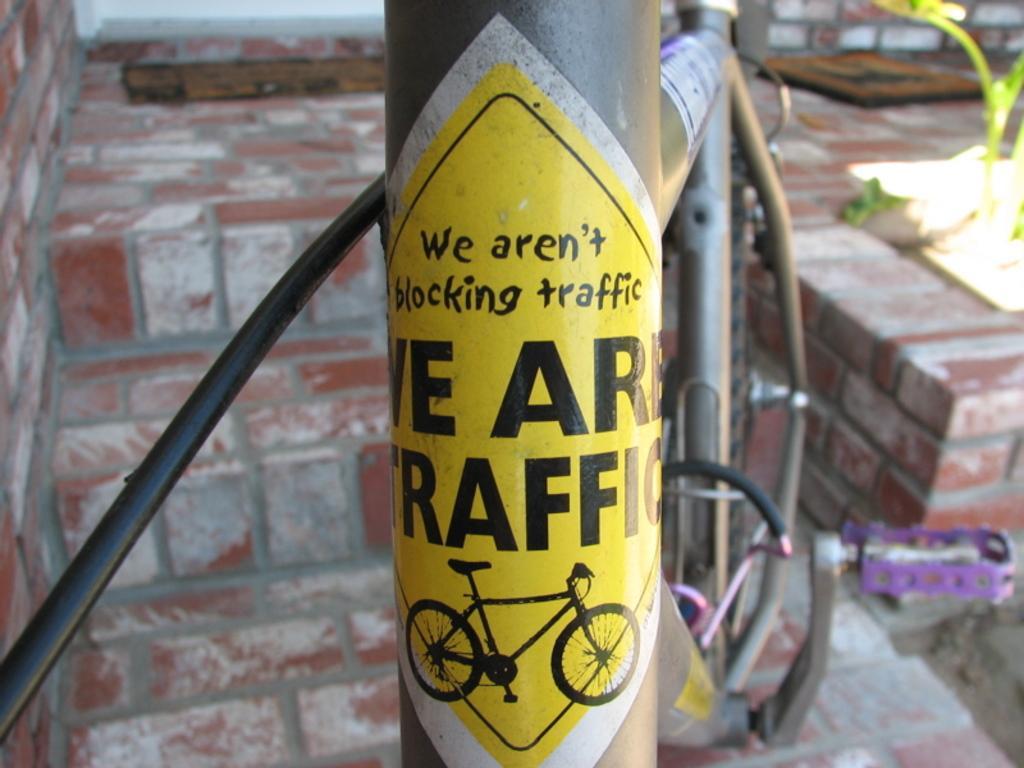Could you give a brief overview of what you see in this image? In this picture we can see a pole with a sticker to it and in the background we can see a plant, rods, brick wall. 